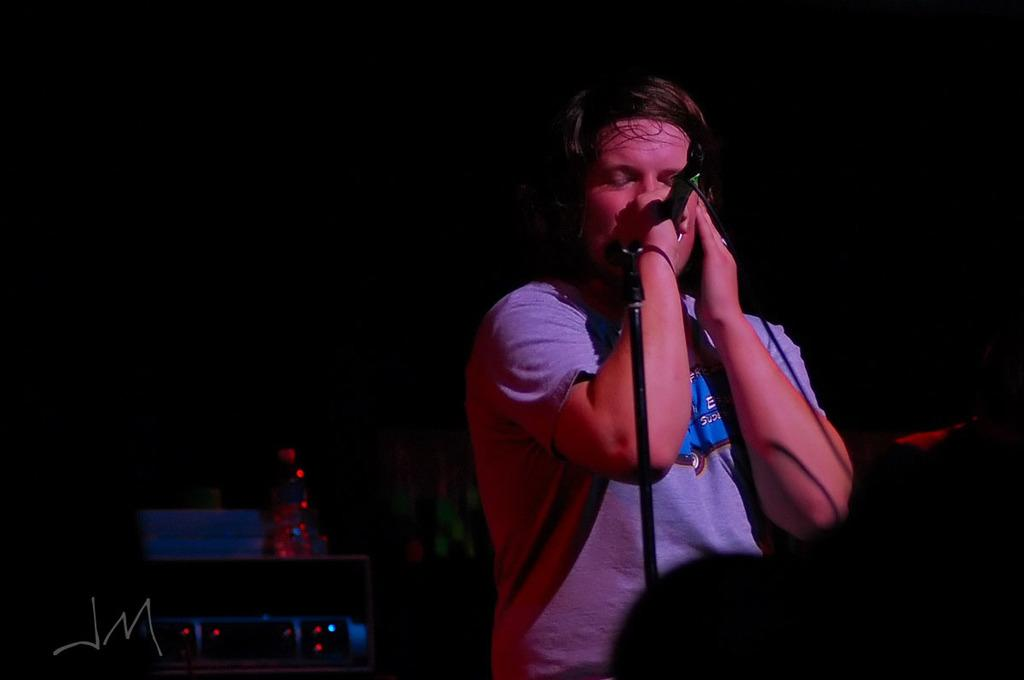What is the main subject of the image? There is a person in the image. What is the person doing in the image? The person is singing in a microphone. Can you describe the person's clothing in the image? The person is wearing a t-shirt. What type of lighting can be seen in the image? There are red color small lights in the middle of the image. What type of drink is the person holding while singing in the image? There is no drink visible in the image; the person is holding a microphone while singing. 